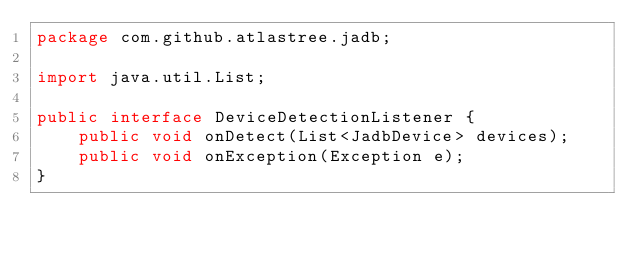<code> <loc_0><loc_0><loc_500><loc_500><_Java_>package com.github.atlastree.jadb;

import java.util.List;

public interface DeviceDetectionListener {
    public void onDetect(List<JadbDevice> devices);
    public void onException(Exception e);
}

</code> 